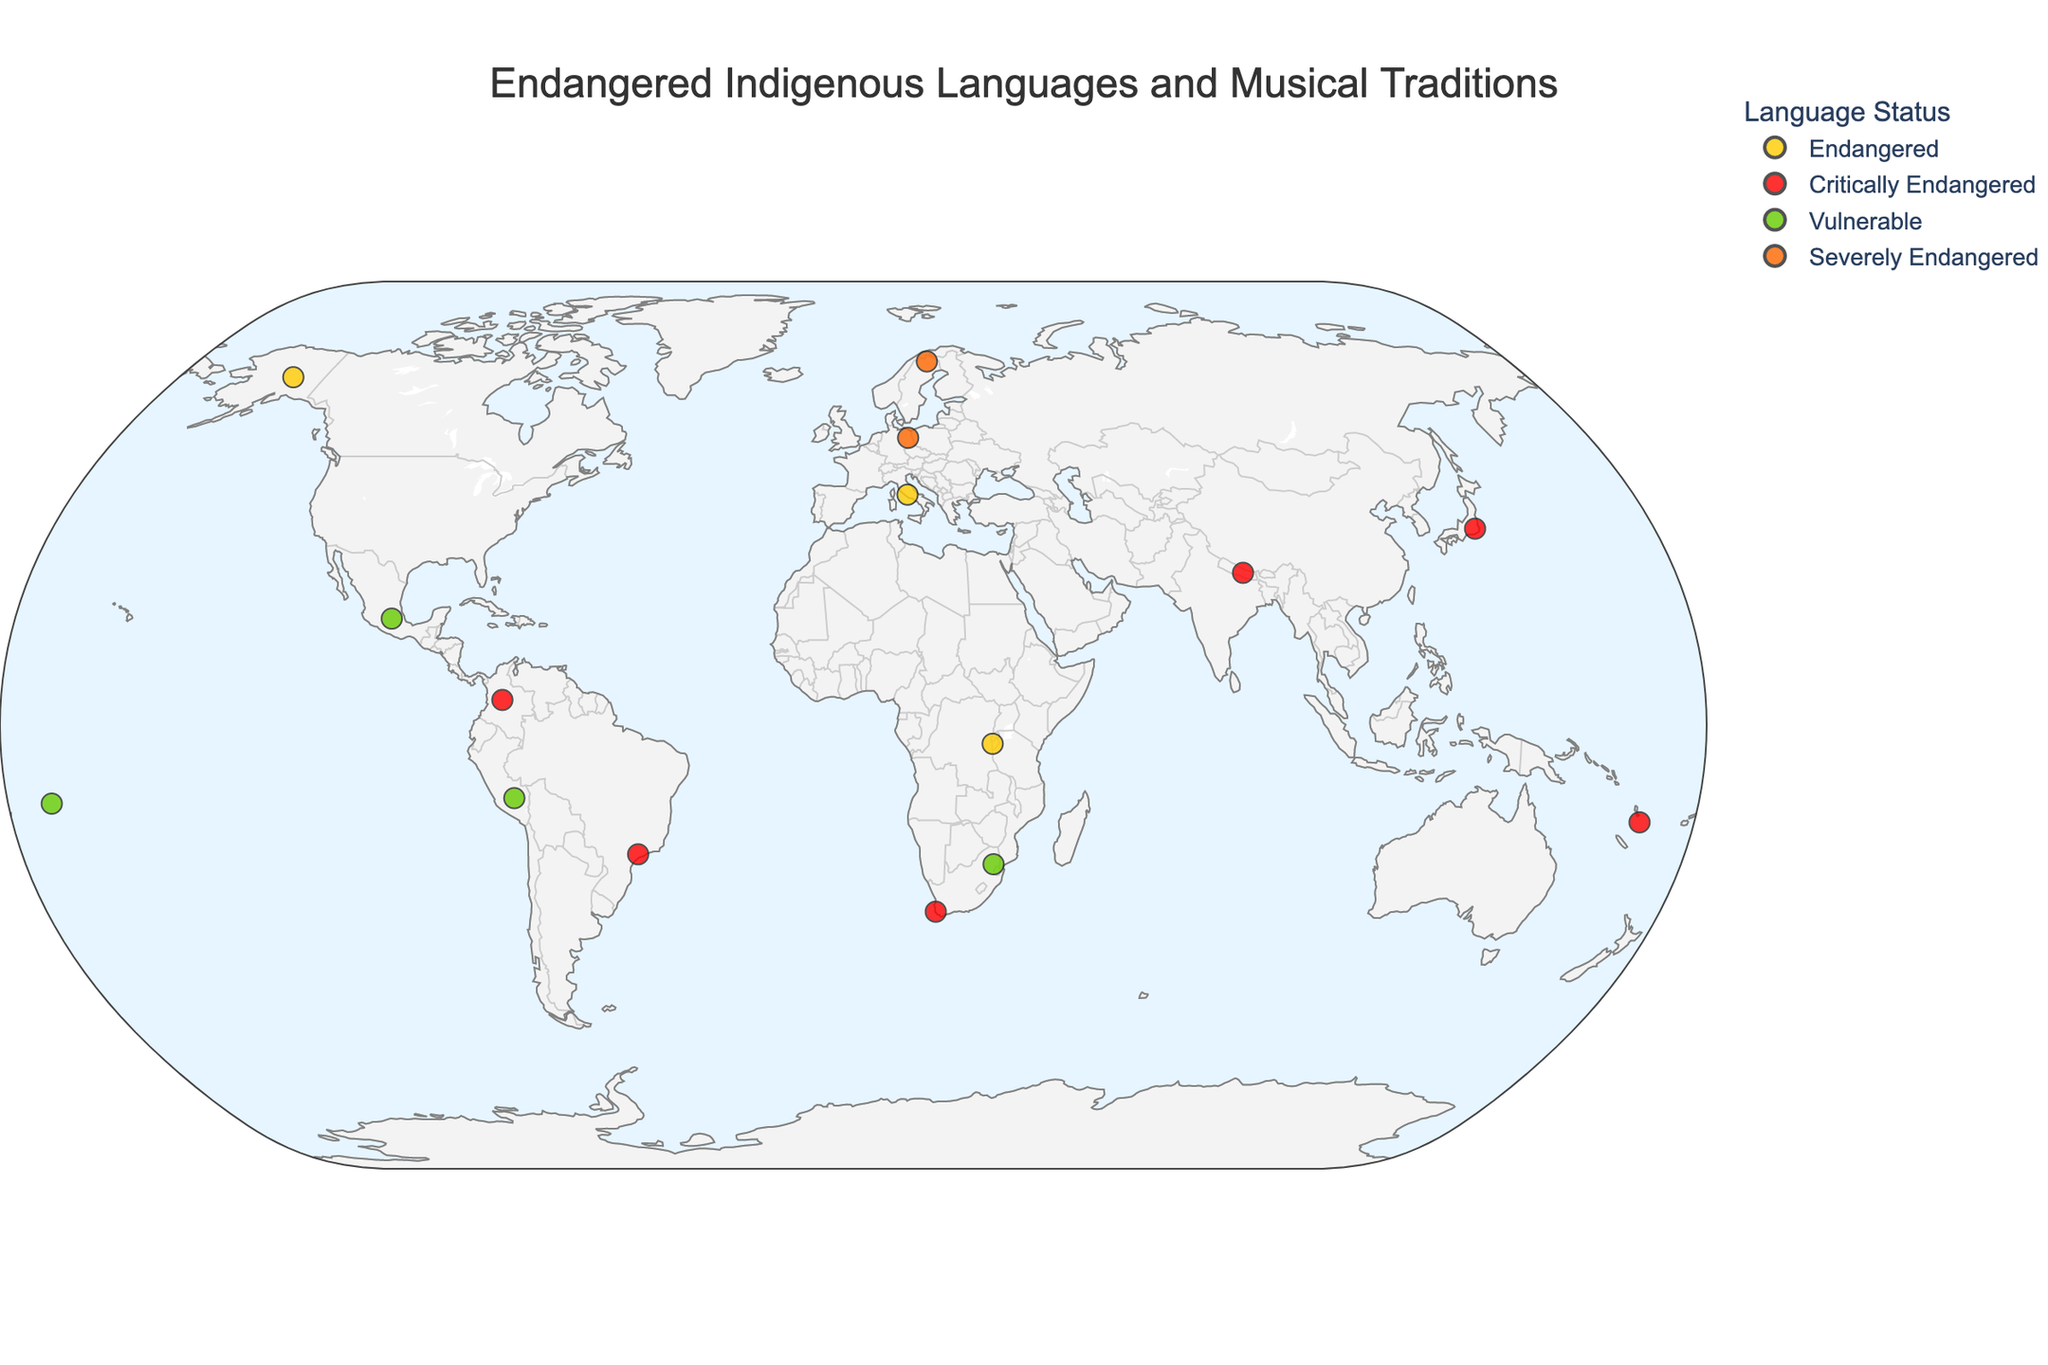How many languages on the map are categorized as "Critically Endangered"? Count the number of points on the map that are colored according to the "Critically Endangered" color in the legend.
Answer: 6 Which country has the "Ainu" language and what is its associated musical tradition? Hover over the point representing "Ainu" on the map to find the associated country and musical tradition.
Answer: Japan, Upopo Chants Which status category has the highest number of languages? Count the number of points for each status category based on their colors and compare the counts.
Answer: Endangered What type of musical tradition is associated with the "Araki" language, and its endangered status? Hover over the point for "Araki" and read the musical tradition and language status from the hover information provided.
Answer: Kastom Music, Critically Endangered Is there any language in South America categorized as "Vulnerable"? Look at the South America region on the map and identify if there are any points with the "Vulnerable" color.
Answer: Yes, Quechua in Peru What's the common status among the languages with musical traditions related to dance? Identify languages with dance-related musical traditions (e.g., "Sibhaca Dance Music", "Fatele Dance Songs") and check their status.
Answer: Vulnerable Which language is spread to the furthest north, and what is its status? Identify the furthest north point on the map and check the language and status from the hover information.
Answer: Gwich'in, Endangered How many languages in Africa are included in the map and what are their musical traditions? Count the points in the Africa region and read their musical traditions from the hover information.
Answer: 3, Sibhaca Dance Music, Pygmy Polyphony, Khoisan Click Songs Which languages fall under the "Severely Endangered" category, and where are they located? Identify points of the "Severely Endangered" color and read their names and locations from the hover information.
Answer: Lower Sorbian in Germany, Lule Sami in Sweden Is there a concentration of critically endangered languages within a specific continent? Look at the distribution of critically endangered languages (red points) and gauge if they are densely located on any specific continent.
Answer: No, they are broadly distributed 